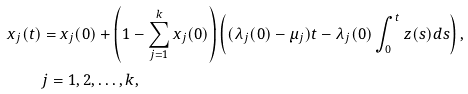<formula> <loc_0><loc_0><loc_500><loc_500>x _ { j } ( t ) & = x _ { j } ( 0 ) + \left ( 1 - \sum _ { j = 1 } ^ { k } x _ { j } ( 0 ) \right ) \left ( ( \lambda _ { j } ( 0 ) - \mu _ { j } ) t - \lambda _ { j } ( 0 ) \int _ { 0 } ^ { t } z ( s ) d s \right ) , \\ & j = 1 , 2 , \dots , k ,</formula> 